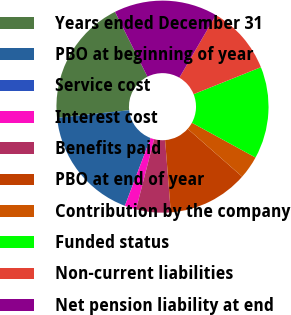<chart> <loc_0><loc_0><loc_500><loc_500><pie_chart><fcel>Years ended December 31<fcel>PBO at beginning of year<fcel>Service cost<fcel>Interest cost<fcel>Benefits paid<fcel>PBO at end of year<fcel>Contribution by the company<fcel>Funded status<fcel>Non-current liabilities<fcel>Net pension liability at end<nl><fcel>19.3%<fcel>17.54%<fcel>0.0%<fcel>1.76%<fcel>5.26%<fcel>12.28%<fcel>3.51%<fcel>14.03%<fcel>10.53%<fcel>15.79%<nl></chart> 